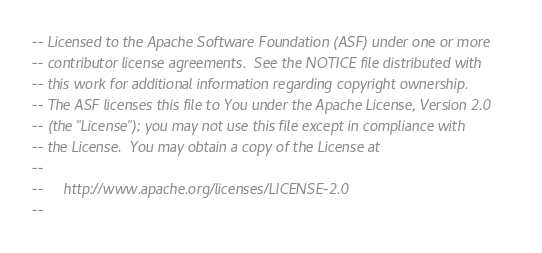<code> <loc_0><loc_0><loc_500><loc_500><_SQL_>-- Licensed to the Apache Software Foundation (ASF) under one or more
-- contributor license agreements.  See the NOTICE file distributed with
-- this work for additional information regarding copyright ownership.
-- The ASF licenses this file to You under the Apache License, Version 2.0
-- (the "License"); you may not use this file except in compliance with
-- the License.  You may obtain a copy of the License at
--
--     http://www.apache.org/licenses/LICENSE-2.0
--</code> 